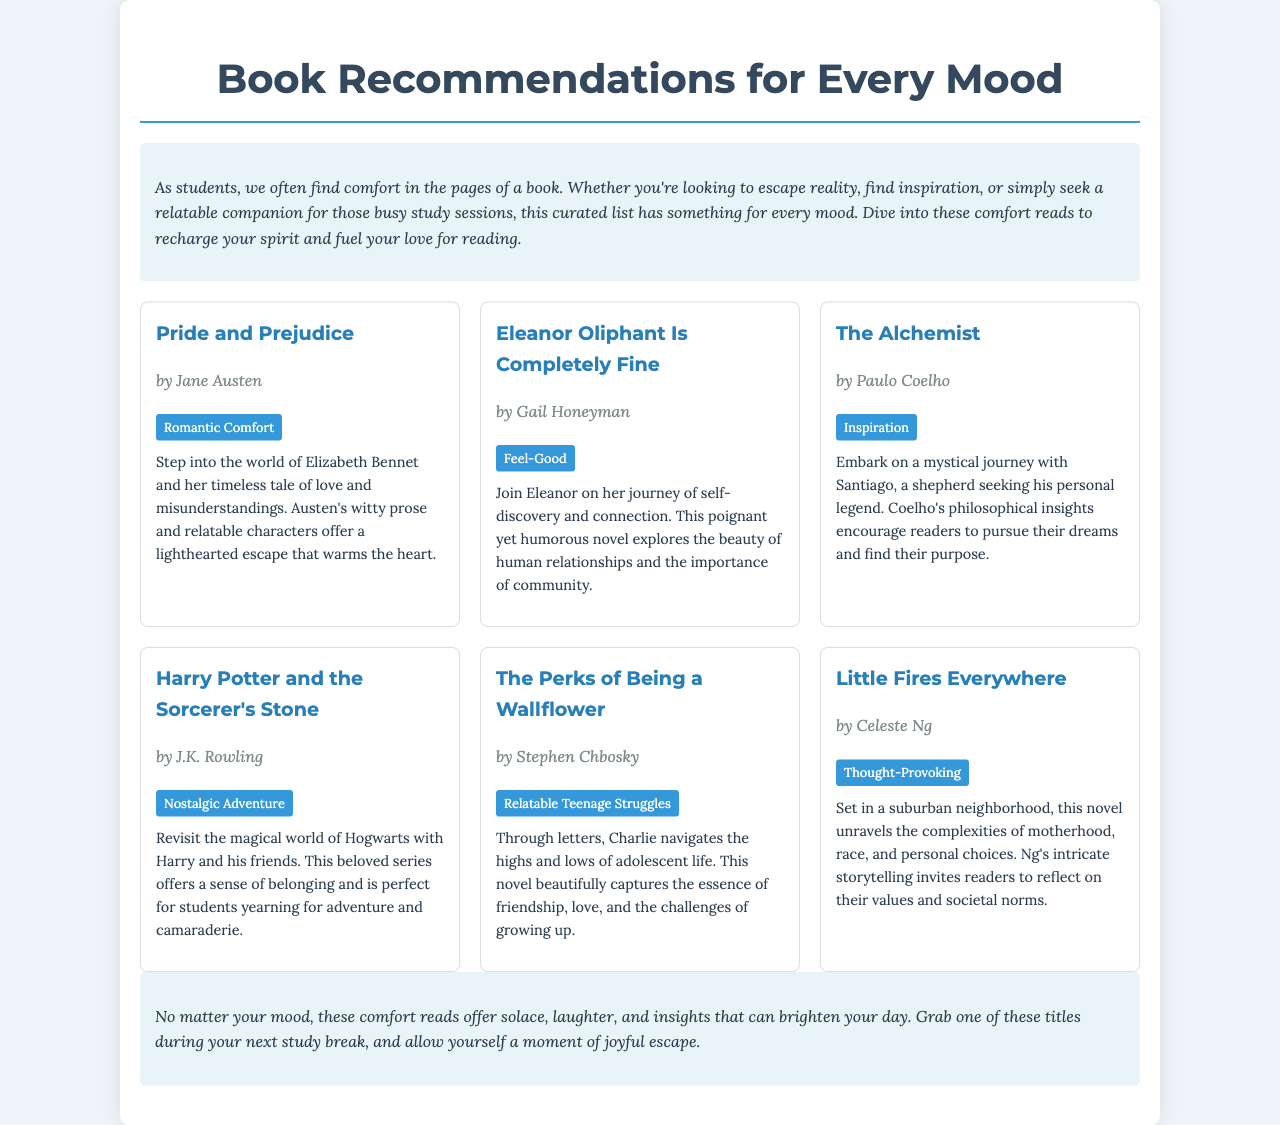What is the title of the first book listed? The first book listed in the brochure is "Pride and Prejudice."
Answer: Pride and Prejudice Who is the author of "Eleanor Oliphant Is Completely Fine"? The author of "Eleanor Oliphant Is Completely Fine" is Gail Honeyman.
Answer: Gail Honeyman What mood is associated with "The Alchemist"? The mood associated with "The Alchemist" is "Inspiration."
Answer: Inspiration Which book offers a sense of belonging and adventure? The book that offers a sense of belonging and adventure is "Harry Potter and the Sorcerer's Stone."
Answer: Harry Potter and the Sorcerer's Stone How many books are listed in total in this brochure? The brochure lists a total of six books.
Answer: Six books What is the main theme of "The Perks of Being a Wallflower"? The main theme of "The Perks of Being a Wallflower" is relatable teenage struggles.
Answer: Relatable Teenage Struggles Which book is referred to as "Thought-Provoking"? The book referred to as "Thought-Provoking" is "Little Fires Everywhere."
Answer: Little Fires Everywhere What do these comfort reads aim to provide for students? These comfort reads aim to provide solace, laughter, and insights.
Answer: Solace, laughter, and insights 